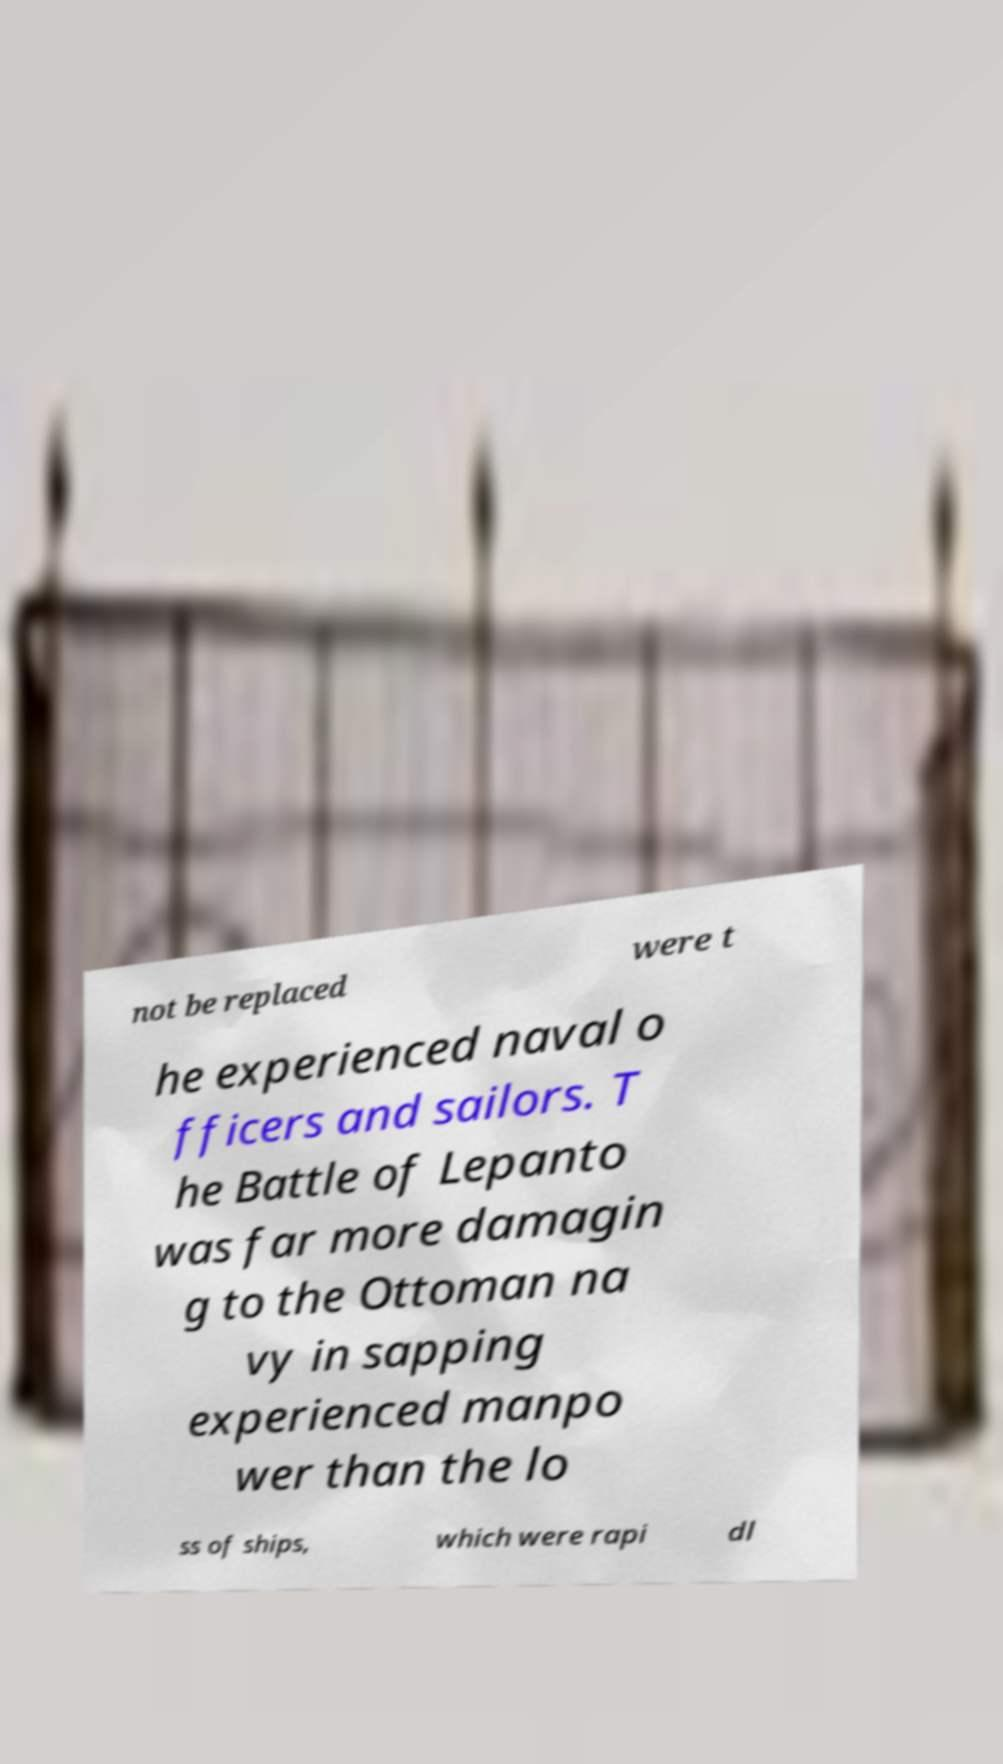Could you assist in decoding the text presented in this image and type it out clearly? not be replaced were t he experienced naval o fficers and sailors. T he Battle of Lepanto was far more damagin g to the Ottoman na vy in sapping experienced manpo wer than the lo ss of ships, which were rapi dl 